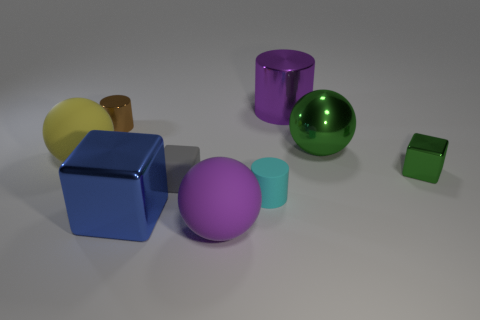Are there any other metal cylinders of the same color as the big metallic cylinder?
Provide a succinct answer. No. Is the number of large yellow things that are behind the metallic ball less than the number of tiny brown metal cylinders?
Your response must be concise. Yes. Does the sphere to the left of the blue object have the same size as the big green metallic ball?
Ensure brevity in your answer.  Yes. What number of things are behind the big purple matte thing and right of the big blue metal thing?
Make the answer very short. 5. What is the size of the brown metallic cylinder in front of the metal object that is behind the small brown metallic cylinder?
Offer a very short reply. Small. Are there fewer gray rubber blocks that are to the left of the small gray cube than big purple matte spheres that are behind the large blue thing?
Give a very brief answer. No. Does the matte object in front of the small cyan rubber thing have the same color as the large rubber ball left of the brown cylinder?
Give a very brief answer. No. There is a thing that is in front of the purple shiny cylinder and behind the big metallic sphere; what is its material?
Keep it short and to the point. Metal. Are there any purple objects?
Your answer should be very brief. Yes. What shape is the large green thing that is the same material as the blue block?
Your answer should be compact. Sphere. 